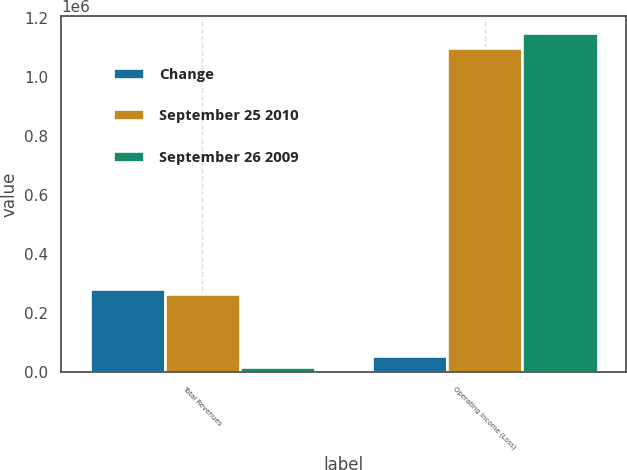Convert chart. <chart><loc_0><loc_0><loc_500><loc_500><stacked_bar_chart><ecel><fcel>Total Revenues<fcel>Operating Income (Loss)<nl><fcel>Change<fcel>283142<fcel>53071<nl><fcel>September 25 2010<fcel>264900<fcel>1.09768e+06<nl><fcel>September 26 2009<fcel>18242<fcel>1.15076e+06<nl></chart> 